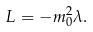<formula> <loc_0><loc_0><loc_500><loc_500>L = - m _ { 0 } ^ { 2 } \lambda .</formula> 